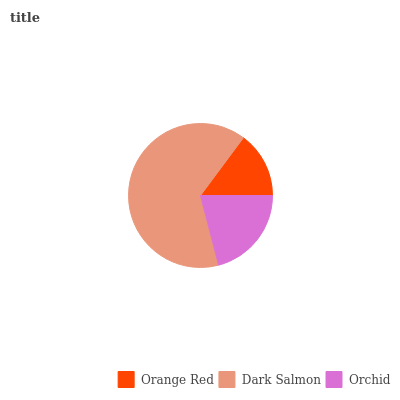Is Orange Red the minimum?
Answer yes or no. Yes. Is Dark Salmon the maximum?
Answer yes or no. Yes. Is Orchid the minimum?
Answer yes or no. No. Is Orchid the maximum?
Answer yes or no. No. Is Dark Salmon greater than Orchid?
Answer yes or no. Yes. Is Orchid less than Dark Salmon?
Answer yes or no. Yes. Is Orchid greater than Dark Salmon?
Answer yes or no. No. Is Dark Salmon less than Orchid?
Answer yes or no. No. Is Orchid the high median?
Answer yes or no. Yes. Is Orchid the low median?
Answer yes or no. Yes. Is Dark Salmon the high median?
Answer yes or no. No. Is Dark Salmon the low median?
Answer yes or no. No. 